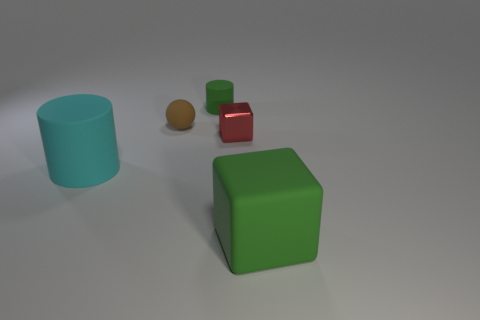Do the tiny block and the cube that is in front of the cyan thing have the same color?
Your response must be concise. No. There is a cylinder that is the same color as the rubber cube; what is it made of?
Offer a very short reply. Rubber. Is there anything else that is the same shape as the cyan rubber object?
Ensure brevity in your answer.  Yes. There is a green rubber thing that is behind the rubber thing in front of the matte cylinder that is left of the tiny brown sphere; what shape is it?
Give a very brief answer. Cylinder. What is the shape of the large green thing?
Your answer should be very brief. Cube. There is a large object that is behind the big matte cube; what color is it?
Ensure brevity in your answer.  Cyan. Do the green thing to the right of the red metal cube and the small green rubber cylinder have the same size?
Keep it short and to the point. No. The green rubber object that is the same shape as the red metallic thing is what size?
Provide a short and direct response. Large. Is there anything else that has the same size as the cyan cylinder?
Provide a succinct answer. Yes. Do the small green rubber object and the cyan thing have the same shape?
Offer a terse response. Yes. 